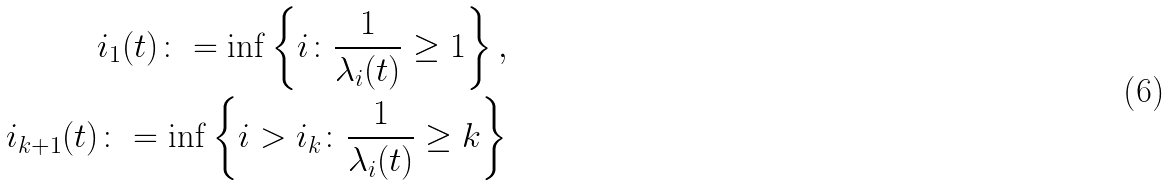Convert formula to latex. <formula><loc_0><loc_0><loc_500><loc_500>i _ { 1 } ( t ) \colon = \inf \left \{ i \colon \frac { 1 } { \lambda _ { i } ( t ) } \geq 1 \right \} , \\ i _ { k + 1 } ( t ) \colon = \inf \left \{ i > i _ { k } \colon \frac { 1 } { \lambda _ { i } ( t ) } \geq k \right \}</formula> 